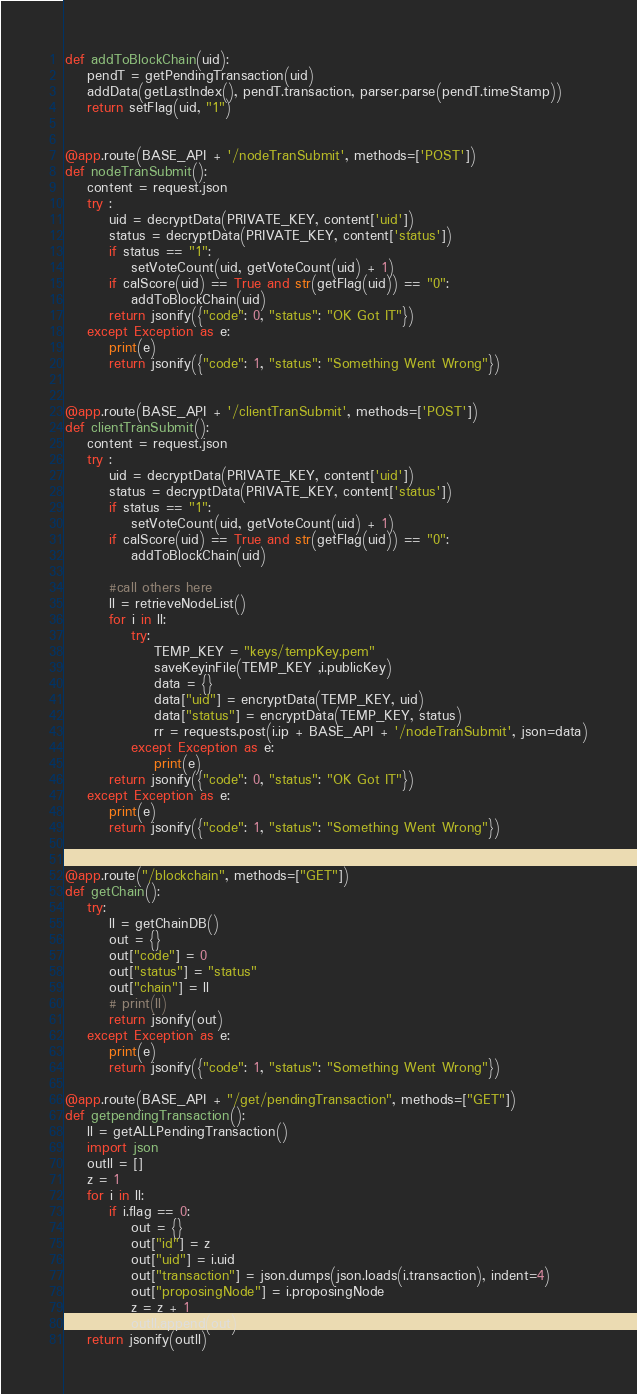Convert code to text. <code><loc_0><loc_0><loc_500><loc_500><_Python_>
def addToBlockChain(uid):
    pendT = getPendingTransaction(uid)
    addData(getLastIndex(), pendT.transaction, parser.parse(pendT.timeStamp))
    return setFlag(uid, "1")


@app.route(BASE_API + '/nodeTranSubmit', methods=['POST'])
def nodeTranSubmit():
    content = request.json
    try :
        uid = decryptData(PRIVATE_KEY, content['uid'])
        status = decryptData(PRIVATE_KEY, content['status'])
        if status == "1":
            setVoteCount(uid, getVoteCount(uid) + 1)
        if calScore(uid) == True and str(getFlag(uid)) == "0":
            addToBlockChain(uid)
        return jsonify({"code": 0, "status": "OK Got IT"})
    except Exception as e:
        print(e)
        return jsonify({"code": 1, "status": "Something Went Wrong"})


@app.route(BASE_API + '/clientTranSubmit', methods=['POST'])
def clientTranSubmit():
    content = request.json
    try :
        uid = decryptData(PRIVATE_KEY, content['uid'])
        status = decryptData(PRIVATE_KEY, content['status'])
        if status == "1":
            setVoteCount(uid, getVoteCount(uid) + 1)
        if calScore(uid) == True and str(getFlag(uid)) == "0":
            addToBlockChain(uid)

        #call others here
        ll = retrieveNodeList()
        for i in ll:
            try:
                TEMP_KEY = "keys/tempKey.pem"
                saveKeyinFile(TEMP_KEY ,i.publicKey)
                data = {}
                data["uid"] = encryptData(TEMP_KEY, uid)
                data["status"] = encryptData(TEMP_KEY, status)
                rr = requests.post(i.ip + BASE_API + '/nodeTranSubmit', json=data)
            except Exception as e:
                print(e)
        return jsonify({"code": 0, "status": "OK Got IT"})
    except Exception as e:
        print(e)
        return jsonify({"code": 1, "status": "Something Went Wrong"})


@app.route("/blockchain", methods=["GET"])
def getChain():
    try:
        ll = getChainDB()
        out = {}
        out["code"] = 0
        out["status"] = "status"
        out["chain"] = ll
        # print(ll)
        return jsonify(out)
    except Exception as e:
        print(e)
        return jsonify({"code": 1, "status": "Something Went Wrong"})

@app.route(BASE_API + "/get/pendingTransaction", methods=["GET"])
def getpendingTransaction():
    ll = getALLPendingTransaction()
    import json
    outll = []
    z = 1
    for i in ll:
        if i.flag == 0:
            out = {}
            out["id"] = z
            out["uid"] = i.uid
            out["transaction"] = json.dumps(json.loads(i.transaction), indent=4)
            out["proposingNode"] = i.proposingNode
            z = z + 1
            outll.append(out)
    return jsonify(outll)</code> 